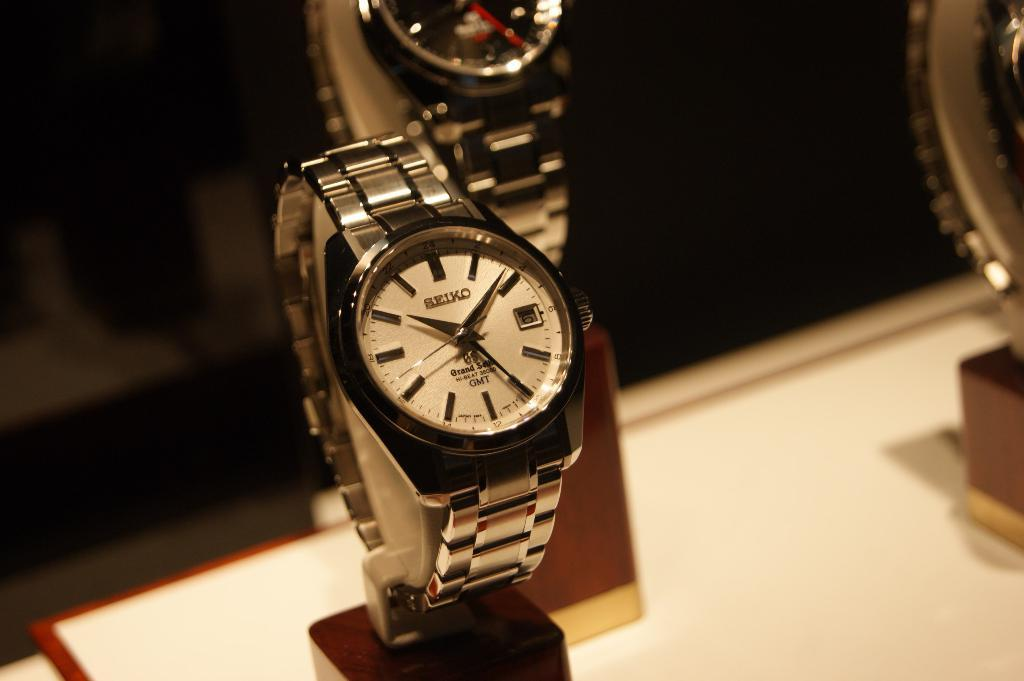<image>
Present a compact description of the photo's key features. A silver watch that says Seiko on the watch face. 